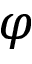Convert formula to latex. <formula><loc_0><loc_0><loc_500><loc_500>\varphi</formula> 